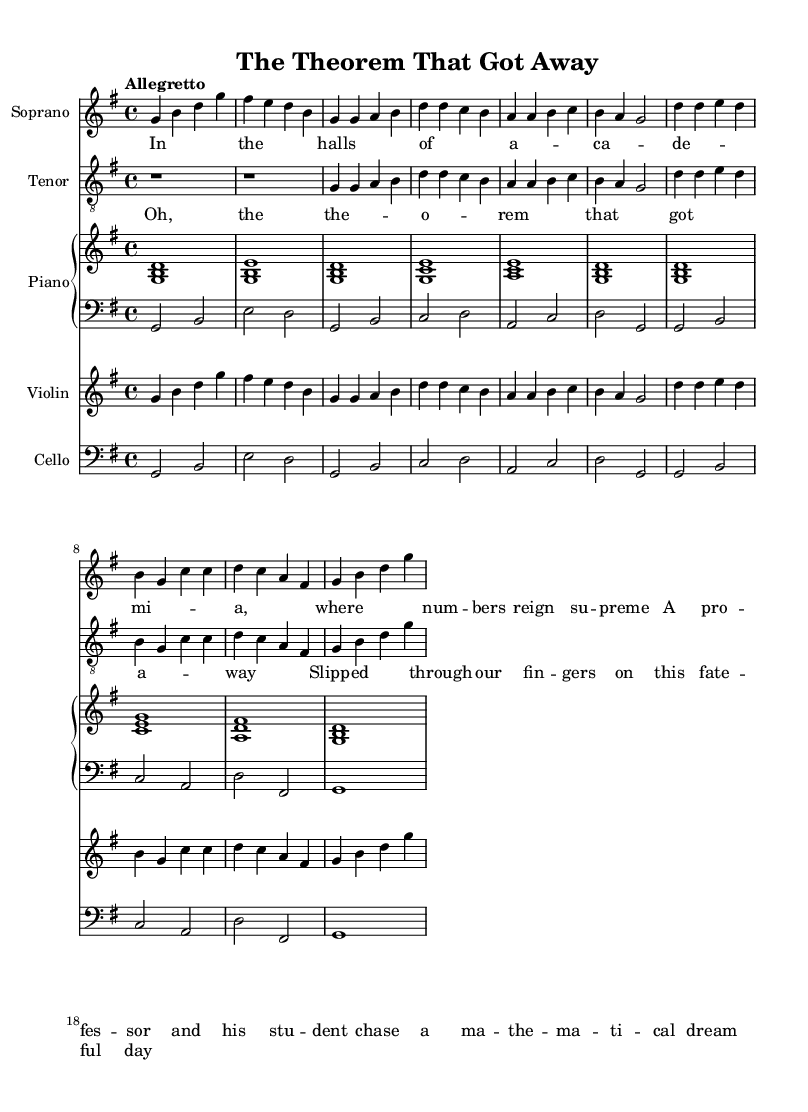What is the key signature of this music? The key signature is identified by looking at the beginning of the staff. In this piece, there are no sharps or flats indicated, which means it is in C major.
Answer: G major What is the time signature of this music? The time signature can be found at the beginning of the piece, which shows how many beats are in each measure. In this case, it reads 4/4, meaning there are four beats per measure.
Answer: 4/4 What is the tempo marking for this piece? The tempo marking is indicated at the beginning of the music, specifying how fast the piece should be played. Here, it states "Allegretto," which is a moderate tempo.
Answer: Allegretto How many measures are in the soprano part? To find the number of measures, count the segments divided by bar lines in the soprano part. There are 8 measures from the start to the end.
Answer: 8 What is the range of the soprano part? The range is determined by the highest and lowest notes written in the soprano line. In this case, the lowest note is G, and the highest note is D.
Answer: G to D What are the lyrics of the first verse? The lyrics can be extracted directly from the lyric mode section. The first verse reads "In the halls of a -- ca -- de -- mi -- a, where num -- bers reign su -- preme."
Answer: In the halls of academia, where numbers reign supreme 